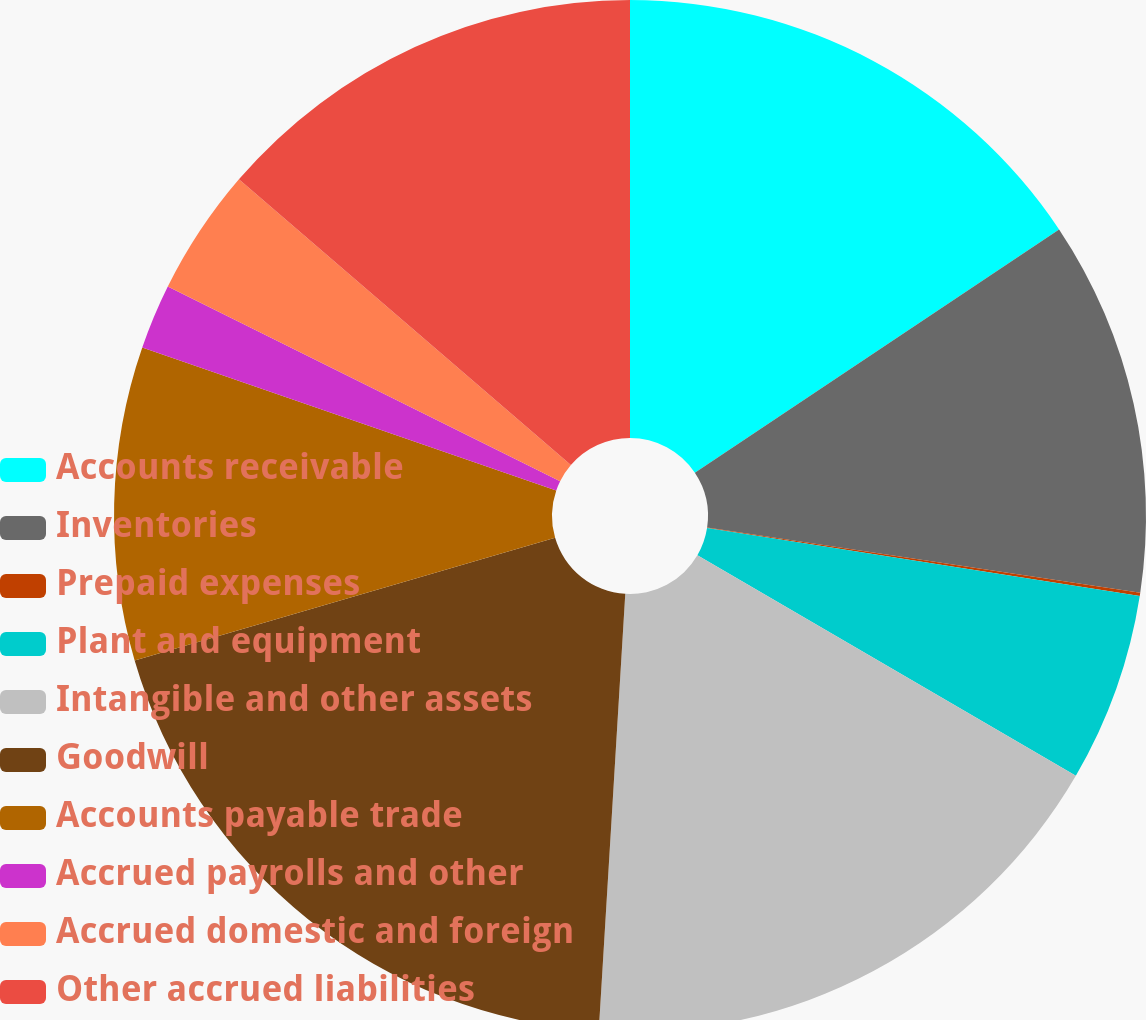Convert chart. <chart><loc_0><loc_0><loc_500><loc_500><pie_chart><fcel>Accounts receivable<fcel>Inventories<fcel>Prepaid expenses<fcel>Plant and equipment<fcel>Intangible and other assets<fcel>Goodwill<fcel>Accounts payable trade<fcel>Accrued payrolls and other<fcel>Accrued domestic and foreign<fcel>Other accrued liabilities<nl><fcel>15.63%<fcel>11.75%<fcel>0.1%<fcel>5.92%<fcel>17.57%<fcel>19.52%<fcel>9.81%<fcel>2.04%<fcel>3.98%<fcel>13.69%<nl></chart> 